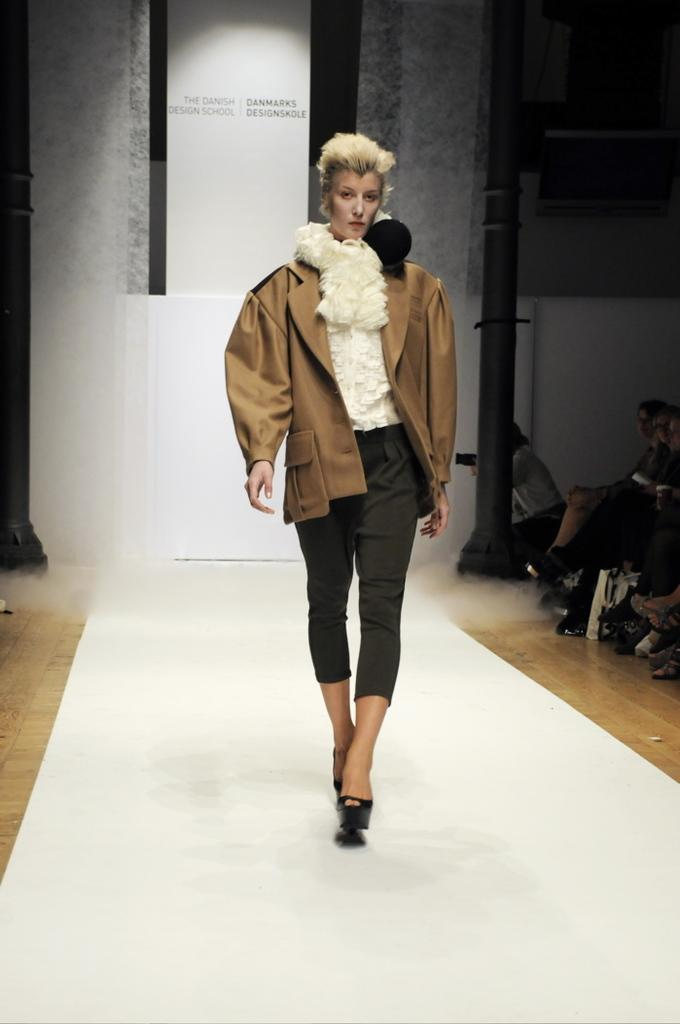What is the lady in the image doing? The lady is walking in the image. Where is the lady walking? The lady is walking on a platform. What can be seen in the background of the image? There are poles in the background of the image. What are the people in the image doing? The people are sitting on the right side of the image. What type of vegetable is being used as a prop by the lady in the image? There is no vegetable present in the image, and the lady is not using any props. 